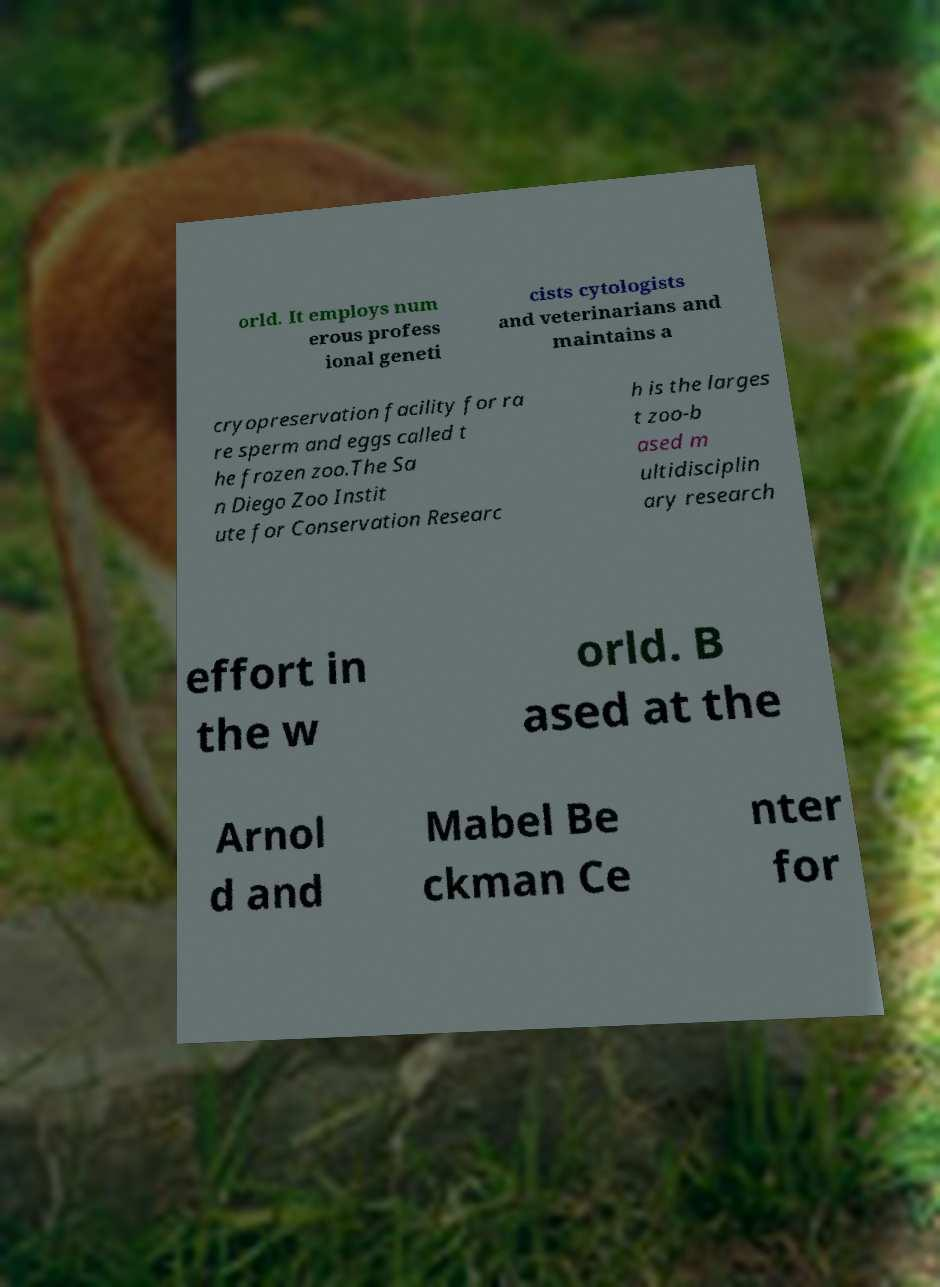Please read and relay the text visible in this image. What does it say? orld. It employs num erous profess ional geneti cists cytologists and veterinarians and maintains a cryopreservation facility for ra re sperm and eggs called t he frozen zoo.The Sa n Diego Zoo Instit ute for Conservation Researc h is the larges t zoo-b ased m ultidisciplin ary research effort in the w orld. B ased at the Arnol d and Mabel Be ckman Ce nter for 